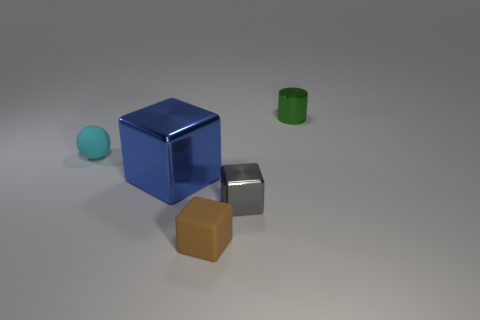There is another matte object that is the same shape as the big thing; what is its color?
Give a very brief answer. Brown. There is a shiny cylinder that is the same size as the cyan matte thing; what is its color?
Ensure brevity in your answer.  Green. Does the cylinder have the same material as the small cyan thing?
Provide a short and direct response. No. How many tiny metal blocks are the same color as the tiny rubber ball?
Your answer should be compact. 0. Is the color of the shiny cylinder the same as the matte ball?
Offer a terse response. No. What material is the block to the right of the tiny brown block?
Make the answer very short. Metal. How many small objects are green metallic cylinders or shiny blocks?
Keep it short and to the point. 2. Are there any cyan balls made of the same material as the big blue block?
Make the answer very short. No. There is a metal thing on the right side of the gray metal object; does it have the same size as the small gray thing?
Keep it short and to the point. Yes. There is a tiny cyan matte thing to the left of the small metal object that is on the left side of the small green cylinder; is there a tiny object behind it?
Ensure brevity in your answer.  Yes. 